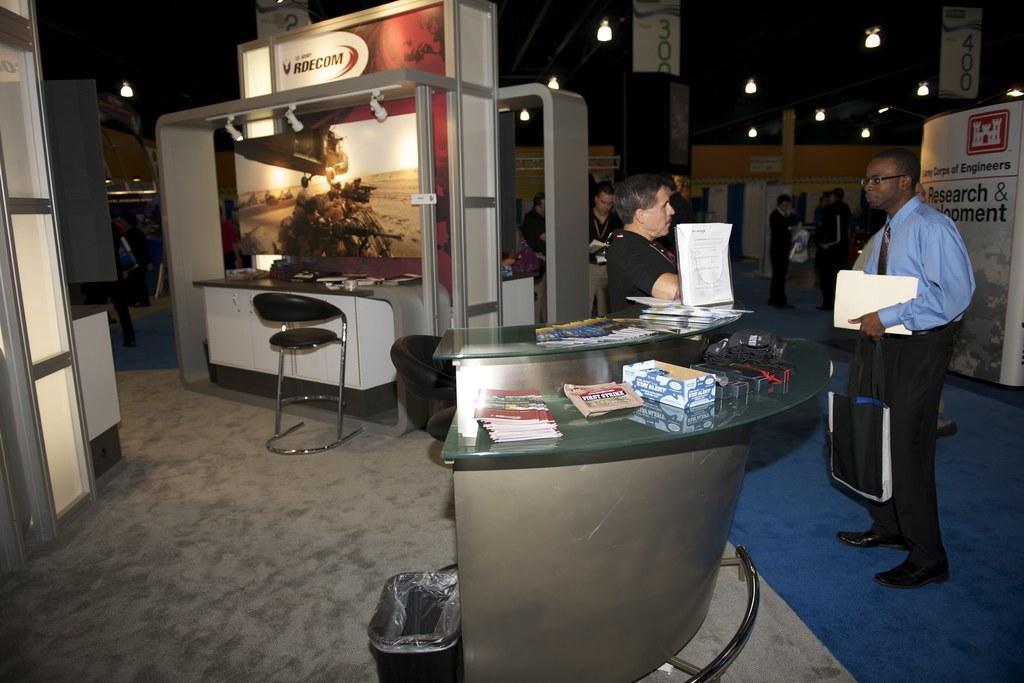Can you describe this image briefly? In the foreground there are two person standing in the right. In the background there are group of people standing. This person is holding a bag in his hand. In the left a person is standing and there is a table in front of that a chair is there and a board is there. And a roof top dark in color visible and lights are mounted on it. This image is taken inside a hall. 